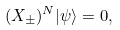Convert formula to latex. <formula><loc_0><loc_0><loc_500><loc_500>( X _ { \pm } ) ^ { N } | \psi \rangle = 0 ,</formula> 